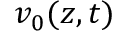<formula> <loc_0><loc_0><loc_500><loc_500>v _ { 0 } ( z , t )</formula> 